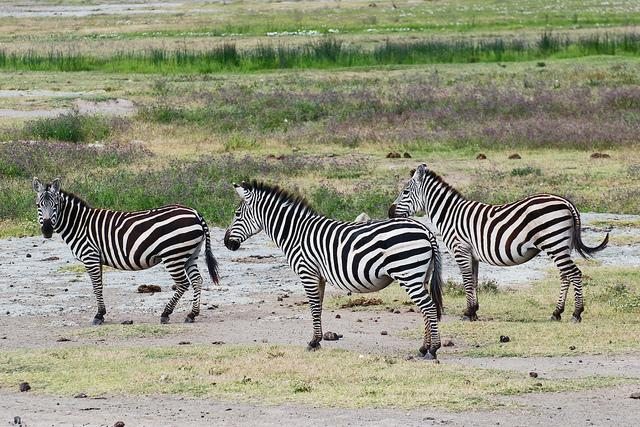What word shares the same first letter as the name of these animals? Please explain your reasoning. zipper. The animals are zebras. 